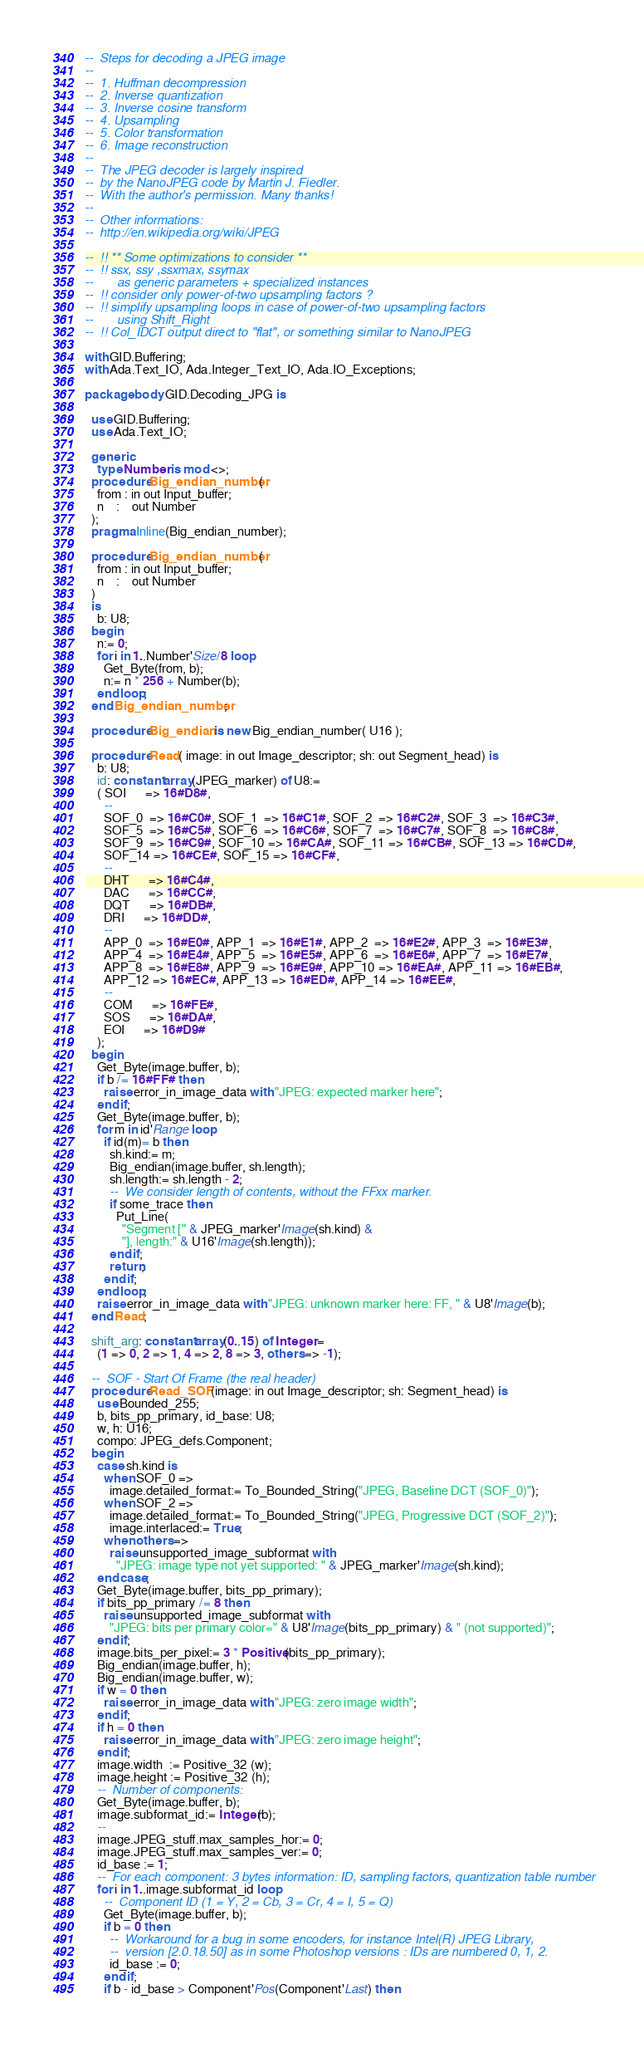<code> <loc_0><loc_0><loc_500><loc_500><_Ada_>--  Steps for decoding a JPEG image
--
--  1. Huffman decompression
--  2. Inverse quantization
--  3. Inverse cosine transform
--  4. Upsampling
--  5. Color transformation
--  6. Image reconstruction
--
--  The JPEG decoder is largely inspired
--  by the NanoJPEG code by Martin J. Fiedler.
--  With the author's permission. Many thanks!
--
--  Other informations:
--  http://en.wikipedia.org/wiki/JPEG

--  !! ** Some optimizations to consider **
--  !! ssx, ssy ,ssxmax, ssymax
--       as generic parameters + specialized instances
--  !! consider only power-of-two upsampling factors ?
--  !! simplify upsampling loops in case of power-of-two upsampling factors
--       using Shift_Right
--  !! Col_IDCT output direct to "flat", or something similar to NanoJPEG

with GID.Buffering;
with Ada.Text_IO, Ada.Integer_Text_IO, Ada.IO_Exceptions;

package body GID.Decoding_JPG is

  use GID.Buffering;
  use Ada.Text_IO;

  generic
    type Number is mod <>;
  procedure Big_endian_number(
    from : in out Input_buffer;
    n    :    out Number
  );
  pragma Inline(Big_endian_number);

  procedure Big_endian_number(
    from : in out Input_buffer;
    n    :    out Number
  )
  is
    b: U8;
  begin
    n:= 0;
    for i in 1..Number'Size/8 loop
      Get_Byte(from, b);
      n:= n * 256 + Number(b);
    end loop;
  end Big_endian_number;

  procedure Big_endian is new Big_endian_number( U16 );

  procedure Read( image: in out Image_descriptor; sh: out Segment_head) is
    b: U8;
    id: constant array(JPEG_marker) of U8:=
    ( SOI      => 16#D8#,
      --
      SOF_0  => 16#C0#, SOF_1  => 16#C1#, SOF_2  => 16#C2#, SOF_3  => 16#C3#,
      SOF_5  => 16#C5#, SOF_6  => 16#C6#, SOF_7  => 16#C7#, SOF_8  => 16#C8#,
      SOF_9  => 16#C9#, SOF_10 => 16#CA#, SOF_11 => 16#CB#, SOF_13 => 16#CD#,
      SOF_14 => 16#CE#, SOF_15 => 16#CF#,
      --
      DHT      => 16#C4#,
      DAC      => 16#CC#,
      DQT      => 16#DB#,
      DRI      => 16#DD#,
      --
      APP_0  => 16#E0#, APP_1  => 16#E1#, APP_2  => 16#E2#, APP_3  => 16#E3#,
      APP_4  => 16#E4#, APP_5  => 16#E5#, APP_6  => 16#E6#, APP_7  => 16#E7#,
      APP_8  => 16#E8#, APP_9  => 16#E9#, APP_10 => 16#EA#, APP_11 => 16#EB#,
      APP_12 => 16#EC#, APP_13 => 16#ED#, APP_14 => 16#EE#,
      --
      COM      => 16#FE#,
      SOS      => 16#DA#,
      EOI      => 16#D9#
    );
  begin
    Get_Byte(image.buffer, b);
    if b /= 16#FF# then
      raise error_in_image_data with "JPEG: expected marker here";
    end if;
    Get_Byte(image.buffer, b);
    for m in id'Range loop
      if id(m)= b then
        sh.kind:= m;
        Big_endian(image.buffer, sh.length);
        sh.length:= sh.length - 2;
        --  We consider length of contents, without the FFxx marker.
        if some_trace then
          Put_Line(
            "Segment [" & JPEG_marker'Image(sh.kind) &
            "], length:" & U16'Image(sh.length));
        end if;
        return;
      end if;
    end loop;
    raise error_in_image_data with "JPEG: unknown marker here: FF, " & U8'Image(b);
  end Read;

  shift_arg: constant array(0..15) of Integer:=
    (1 => 0, 2 => 1, 4 => 2, 8 => 3, others => -1);

  --  SOF - Start Of Frame (the real header)
  procedure Read_SOF(image: in out Image_descriptor; sh: Segment_head) is
    use Bounded_255;
    b, bits_pp_primary, id_base: U8;
    w, h: U16;
    compo: JPEG_defs.Component;
  begin
    case sh.kind is
      when SOF_0 =>
        image.detailed_format:= To_Bounded_String("JPEG, Baseline DCT (SOF_0)");
      when SOF_2 =>
        image.detailed_format:= To_Bounded_String("JPEG, Progressive DCT (SOF_2)");
        image.interlaced:= True;
      when others =>
        raise unsupported_image_subformat with
          "JPEG: image type not yet supported: " & JPEG_marker'Image(sh.kind);
    end case;
    Get_Byte(image.buffer, bits_pp_primary);
    if bits_pp_primary /= 8 then
      raise unsupported_image_subformat with
        "JPEG: bits per primary color=" & U8'Image(bits_pp_primary) & " (not supported)";
    end if;
    image.bits_per_pixel:= 3 * Positive(bits_pp_primary);
    Big_endian(image.buffer, h);
    Big_endian(image.buffer, w);
    if w = 0 then
      raise error_in_image_data with "JPEG: zero image width";
    end if;
    if h = 0 then
      raise error_in_image_data with "JPEG: zero image height";
    end if;
    image.width  := Positive_32 (w);
    image.height := Positive_32 (h);
    --  Number of components:
    Get_Byte(image.buffer, b);
    image.subformat_id:= Integer(b);
    --
    image.JPEG_stuff.max_samples_hor:= 0;
    image.JPEG_stuff.max_samples_ver:= 0;
    id_base := 1;
    --  For each component: 3 bytes information: ID, sampling factors, quantization table number
    for i in 1..image.subformat_id loop
      --  Component ID (1 = Y, 2 = Cb, 3 = Cr, 4 = I, 5 = Q)
      Get_Byte(image.buffer, b);
      if b = 0 then
        --  Workaround for a bug in some encoders, for instance Intel(R) JPEG Library,
        --  version [2.0.18.50] as in some Photoshop versions : IDs are numbered 0, 1, 2.
        id_base := 0;
      end if;
      if b - id_base > Component'Pos(Component'Last) then</code> 